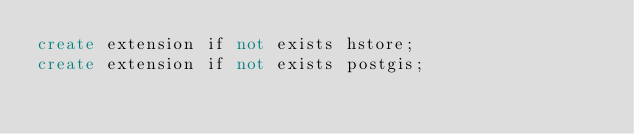Convert code to text. <code><loc_0><loc_0><loc_500><loc_500><_SQL_>create extension if not exists hstore;
create extension if not exists postgis;
</code> 